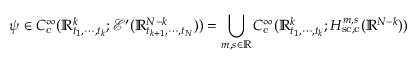<formula> <loc_0><loc_0><loc_500><loc_500>\psi \in C _ { c } ^ { \infty } ( \mathbb { R } _ { t _ { 1 } , \cdots , t _ { k } } ^ { k } ; \mathcal { E } ^ { \prime } ( \mathbb { R } _ { t _ { k + 1 } , \cdots , t _ { N } } ^ { N - k } ) ) = \bigcup _ { m , s \in \mathbb { R } } C _ { c } ^ { \infty } ( \mathbb { R } _ { t _ { 1 } , \cdots , t _ { k } } ^ { k } ; H _ { s c , c } ^ { m , s } ( \mathbb { R } ^ { N - k } ) )</formula> 